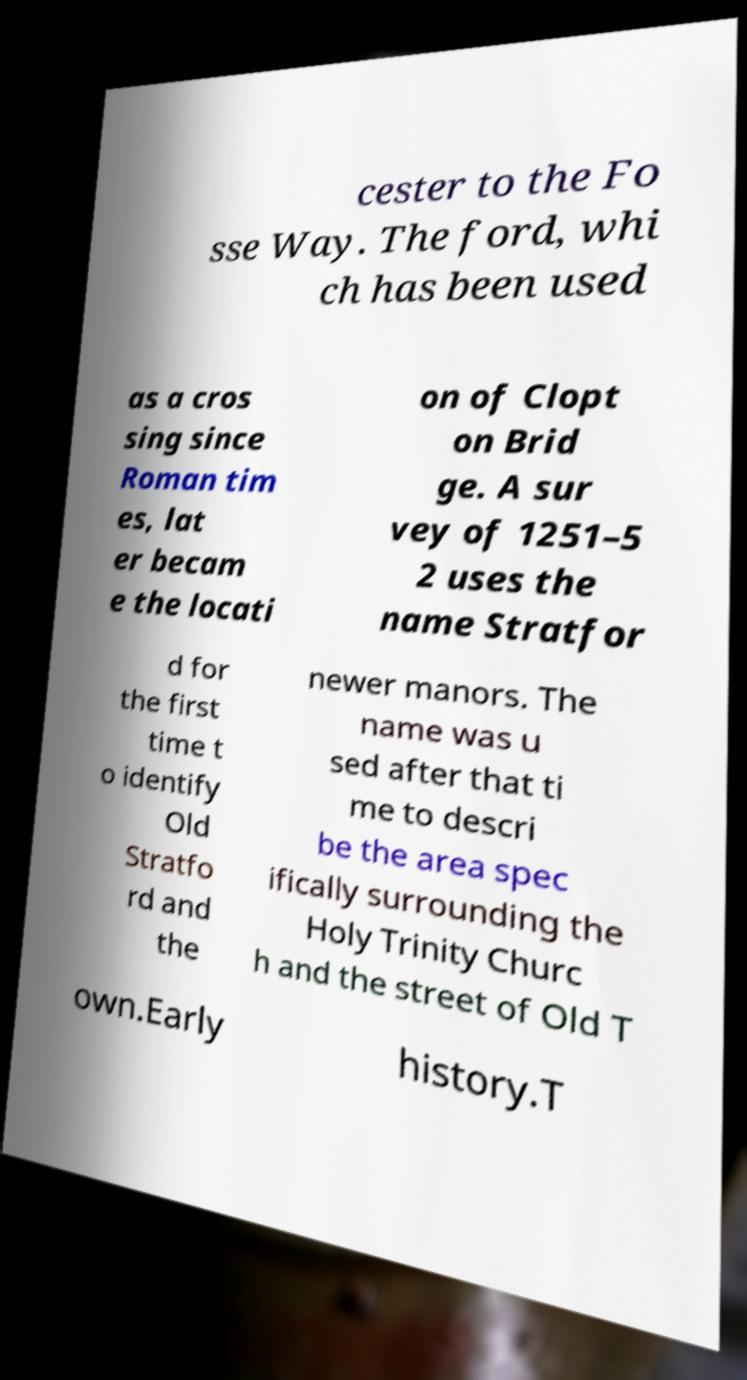Could you assist in decoding the text presented in this image and type it out clearly? cester to the Fo sse Way. The ford, whi ch has been used as a cros sing since Roman tim es, lat er becam e the locati on of Clopt on Brid ge. A sur vey of 1251–5 2 uses the name Stratfor d for the first time t o identify Old Stratfo rd and the newer manors. The name was u sed after that ti me to descri be the area spec ifically surrounding the Holy Trinity Churc h and the street of Old T own.Early history.T 